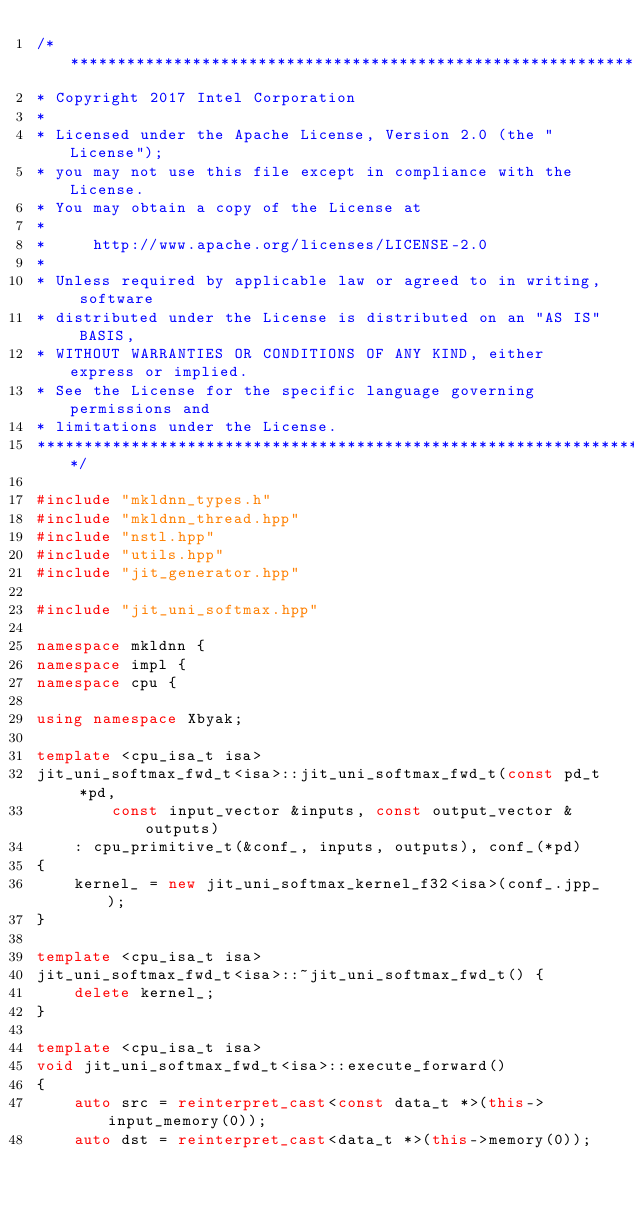<code> <loc_0><loc_0><loc_500><loc_500><_C++_>/*******************************************************************************
* Copyright 2017 Intel Corporation
*
* Licensed under the Apache License, Version 2.0 (the "License");
* you may not use this file except in compliance with the License.
* You may obtain a copy of the License at
*
*     http://www.apache.org/licenses/LICENSE-2.0
*
* Unless required by applicable law or agreed to in writing, software
* distributed under the License is distributed on an "AS IS" BASIS,
* WITHOUT WARRANTIES OR CONDITIONS OF ANY KIND, either express or implied.
* See the License for the specific language governing permissions and
* limitations under the License.
*******************************************************************************/

#include "mkldnn_types.h"
#include "mkldnn_thread.hpp"
#include "nstl.hpp"
#include "utils.hpp"
#include "jit_generator.hpp"

#include "jit_uni_softmax.hpp"

namespace mkldnn {
namespace impl {
namespace cpu {

using namespace Xbyak;

template <cpu_isa_t isa>
jit_uni_softmax_fwd_t<isa>::jit_uni_softmax_fwd_t(const pd_t *pd,
        const input_vector &inputs, const output_vector &outputs)
    : cpu_primitive_t(&conf_, inputs, outputs), conf_(*pd)
{
    kernel_ = new jit_uni_softmax_kernel_f32<isa>(conf_.jpp_);
}

template <cpu_isa_t isa>
jit_uni_softmax_fwd_t<isa>::~jit_uni_softmax_fwd_t() {
    delete kernel_;
}

template <cpu_isa_t isa>
void jit_uni_softmax_fwd_t<isa>::execute_forward()
{
    auto src = reinterpret_cast<const data_t *>(this->input_memory(0));
    auto dst = reinterpret_cast<data_t *>(this->memory(0));
</code> 